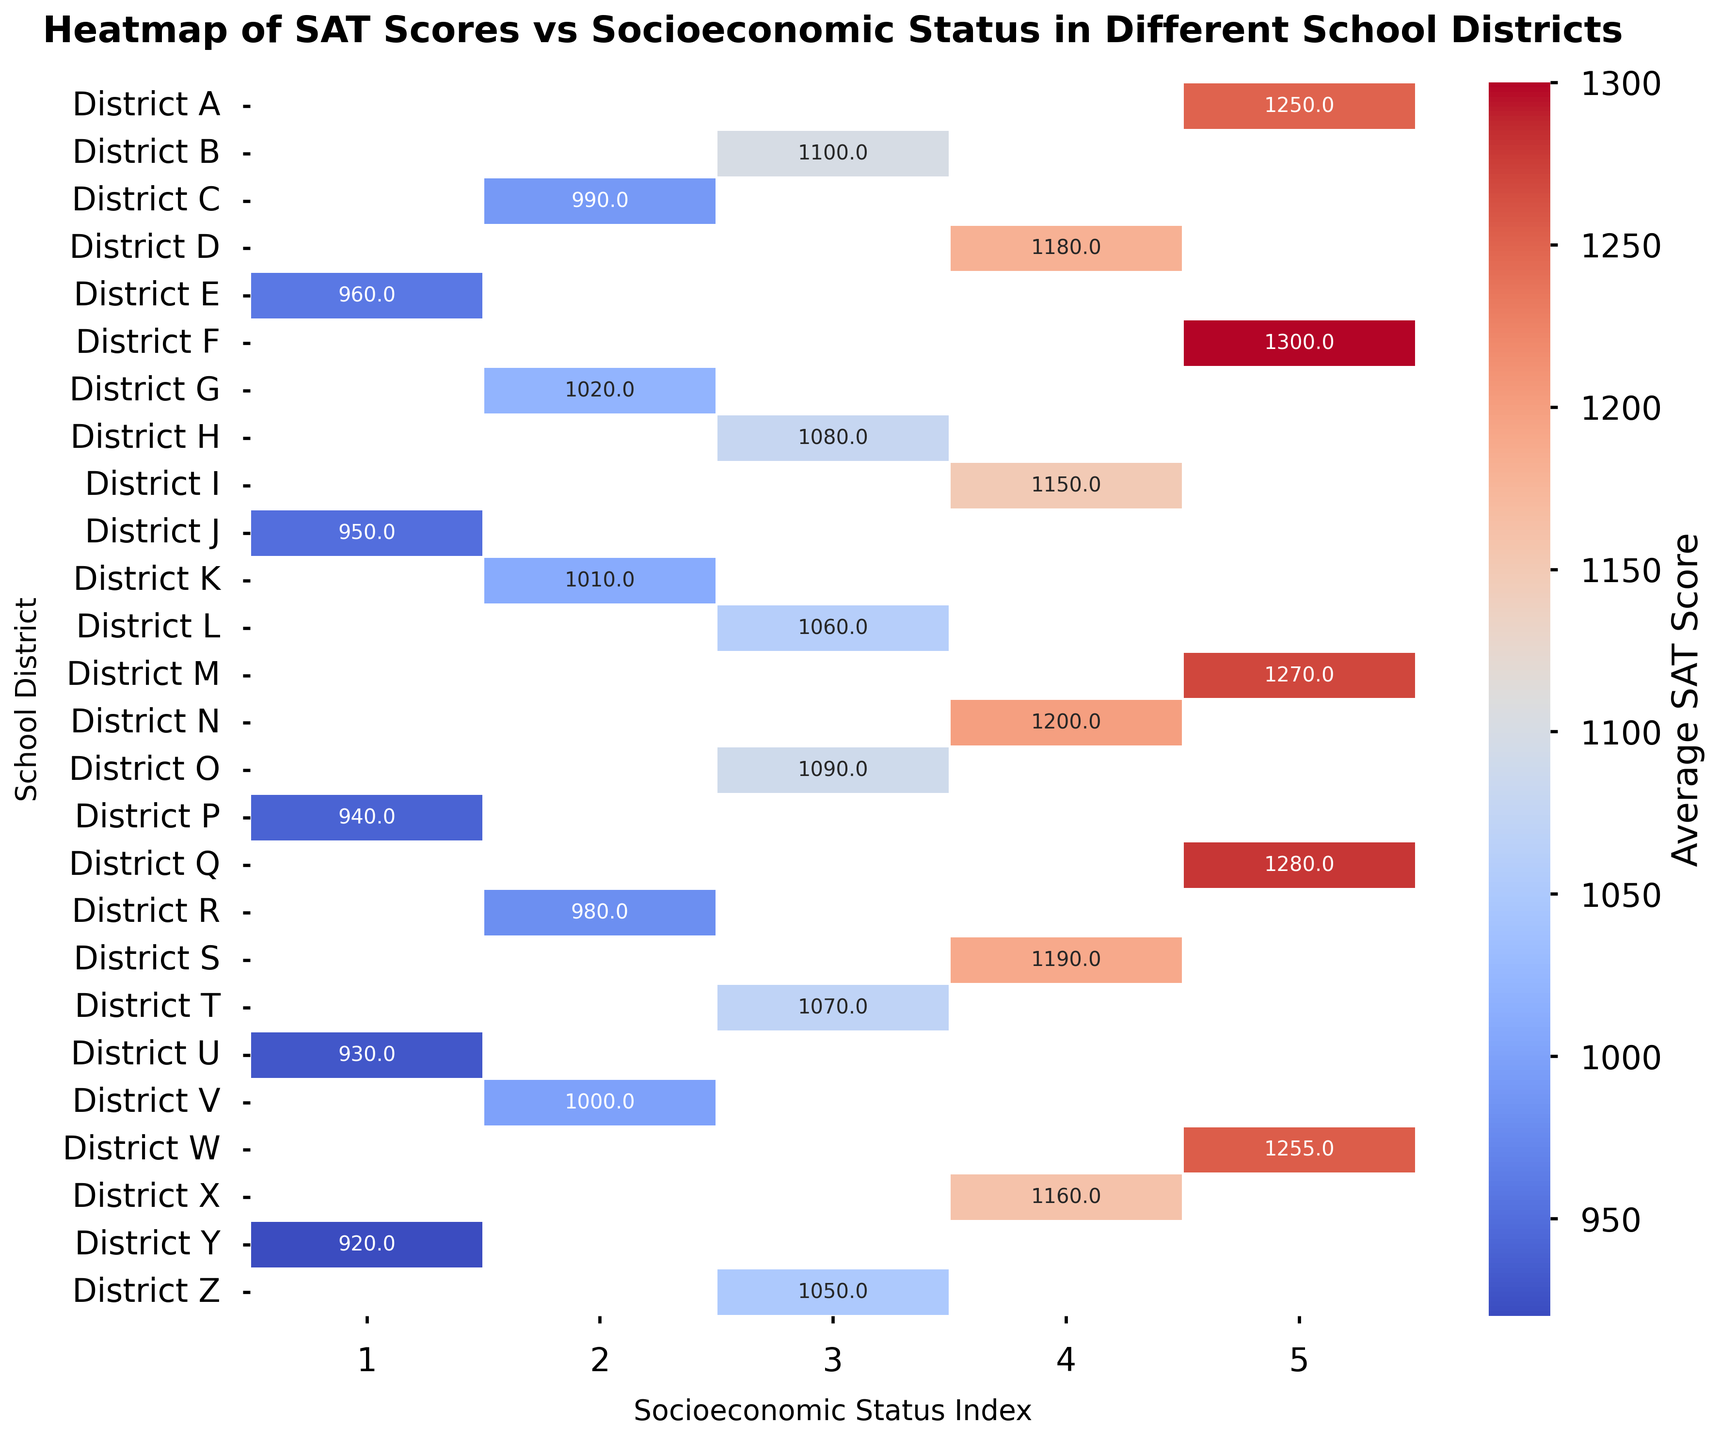What is the SAT average score for District A with the highest socioeconomic status index? Locate District A on the y-axis, then find the box corresponding to the highest socioeconomic status index (5) on the x-axis. The intersecting cell shows the average SAT score.
Answer: 1250 Which school district has the lowest SAT average score for a socioeconomic status index of 2? Locate the socioeconomic status index of 2 on the x-axis. Compare the values in the column below to identify the lowest SAT score and note the corresponding school district on the y-axis.
Answer: District R What is the difference between the SAT average scores for District N and District I when their socioeconomic status index is 4? Locate District N and District I on the y-axis, both with a socioeconomic status index of 4 (x-axis). Subtract the SAT average score of District I from that of District N (1200 - 1150).
Answer: 50 How many school districts have a socioeconomic status index of 3 and an SAT average score above 1070? Locate the socioeconomic status index of 3 on the x-axis. Count the number of cells in the column that have a value above 1070.
Answer: 1 Which socioeconomic status index corresponds to the school district with the highest SAT average score on the heatmap? Scan the cells to identify the highest SAT average score, then find the corresponding socioeconomic status index on the x-axis.
Answer: 5 Compare the SAT average scores of Districts G and K with a socioeconomic status index of 2. Which district has a higher SAT average score and by how much? Locate District G and District K on the y-axis with a socioeconomic status index of 2 on the x-axis. Compare their SAT scores (1020 for G and 1010 for K) and calculate the difference (1020 - 1010).
Answer: District G by 10 Which color represents the highest SAT average scores in the figure? Identify the color used for the highest SAT average scores visually from the heatmap's color gradient.
Answer: Dark red or equivalent What is the total SAT average score for all school districts with a socioeconomic status index of 1? Locate the socioeconomic status index of 1 on the x-axis. Add the values in the corresponding column to get the total SAT average score (960 + 950 + 940 + 930 + 920).
Answer: 4700 Which district has the most inconsistent SAT average scores across different socioeconomic status indices? Scan horizontally across all rows to find the district with the largest range in SAT scores across different indices.
Answer: Varies (requires careful scanning) 